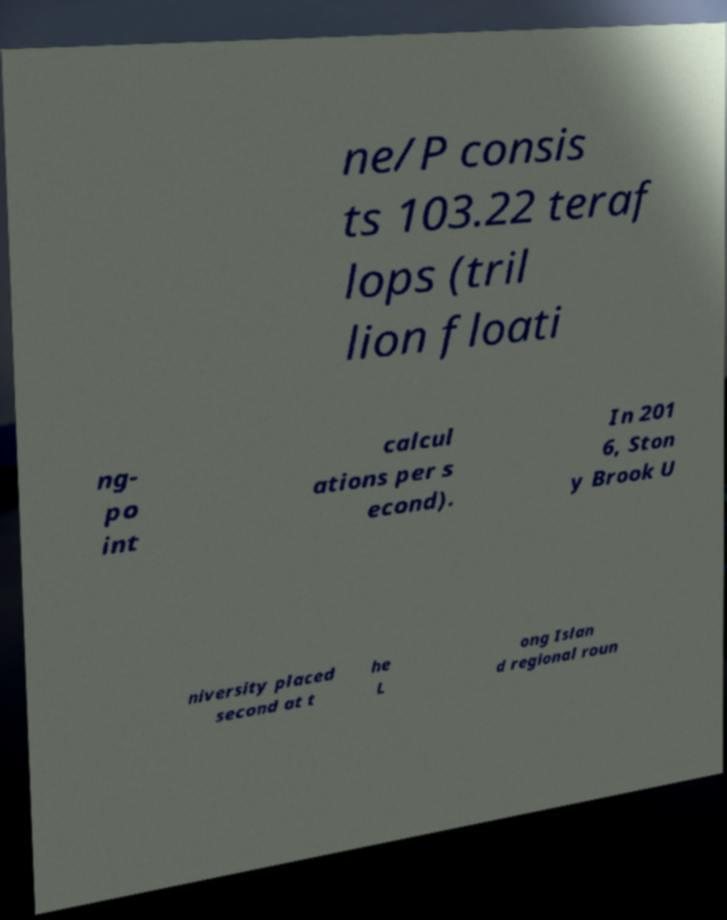Please identify and transcribe the text found in this image. ne/P consis ts 103.22 teraf lops (tril lion floati ng- po int calcul ations per s econd). In 201 6, Ston y Brook U niversity placed second at t he L ong Islan d regional roun 